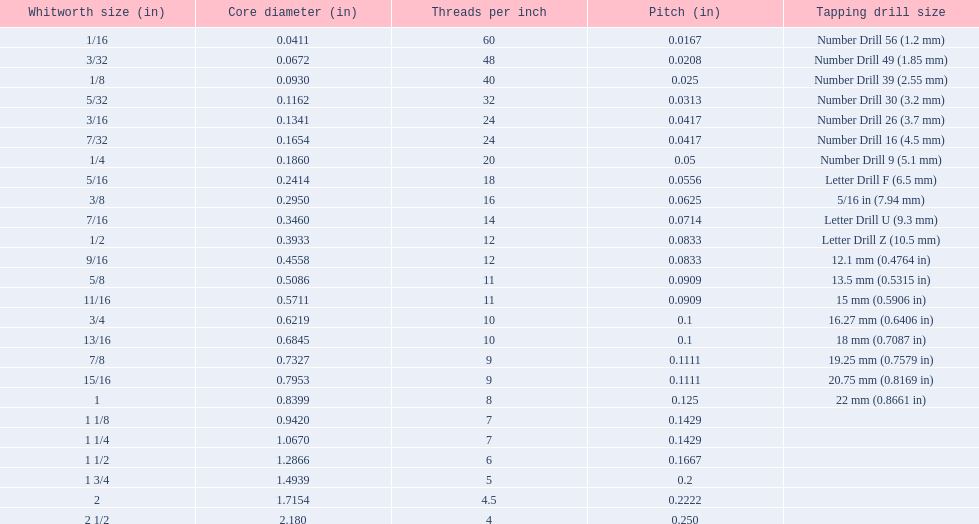What is the inner diameter of a 1/16 whitworth? 0.0411. Which whitworth dimension has the same pitch as a 1/2? 9/16. A 3/16 whitworth possesses the same quantity of threads as? 7/32. 